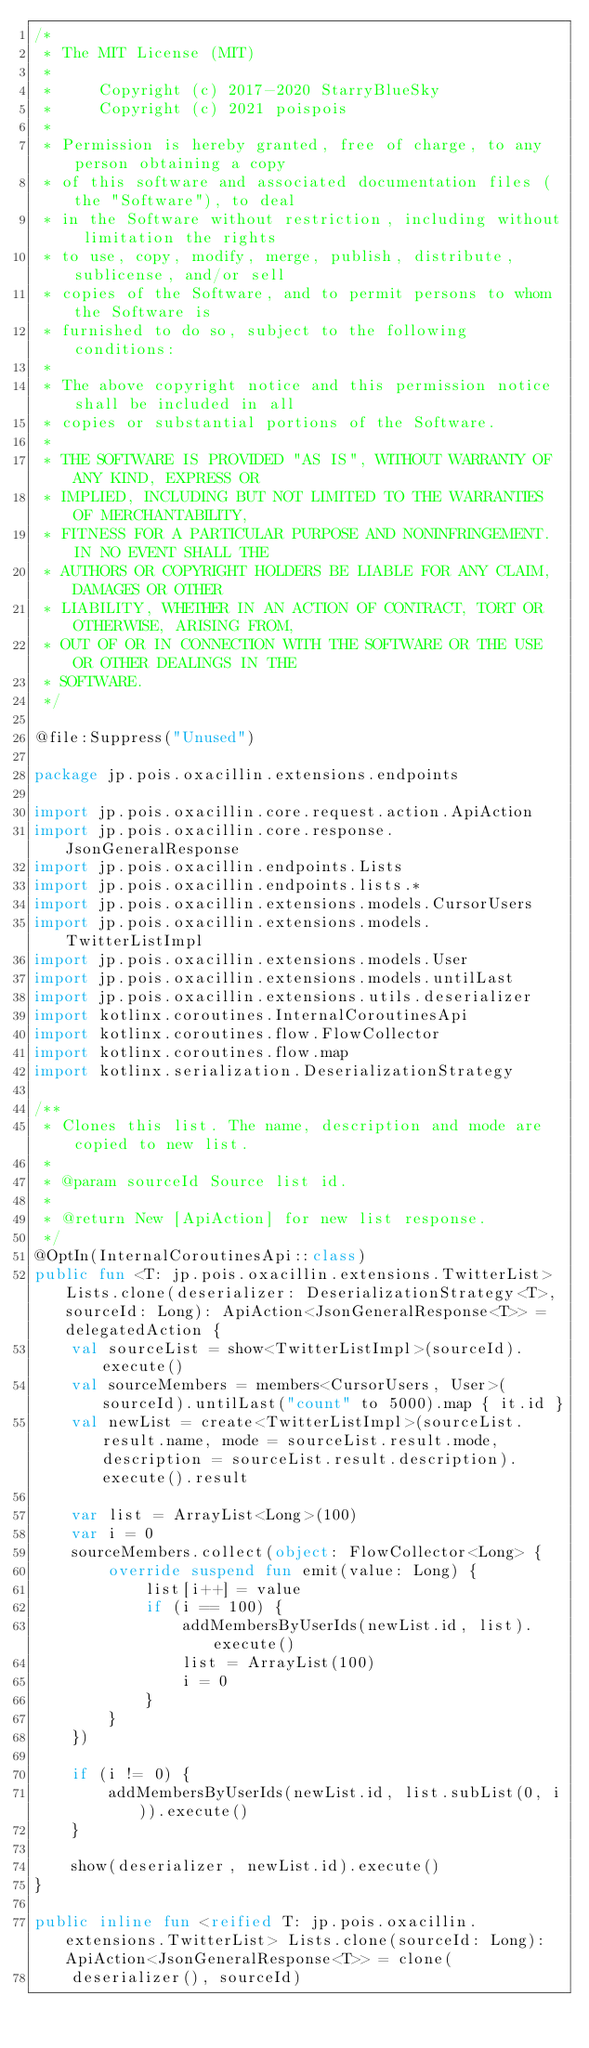Convert code to text. <code><loc_0><loc_0><loc_500><loc_500><_Kotlin_>/*
 * The MIT License (MIT)
 *
 *     Copyright (c) 2017-2020 StarryBlueSky
 *     Copyright (c) 2021 poispois
 *
 * Permission is hereby granted, free of charge, to any person obtaining a copy
 * of this software and associated documentation files (the "Software"), to deal
 * in the Software without restriction, including without limitation the rights
 * to use, copy, modify, merge, publish, distribute, sublicense, and/or sell
 * copies of the Software, and to permit persons to whom the Software is
 * furnished to do so, subject to the following conditions:
 *
 * The above copyright notice and this permission notice shall be included in all
 * copies or substantial portions of the Software.
 *
 * THE SOFTWARE IS PROVIDED "AS IS", WITHOUT WARRANTY OF ANY KIND, EXPRESS OR
 * IMPLIED, INCLUDING BUT NOT LIMITED TO THE WARRANTIES OF MERCHANTABILITY,
 * FITNESS FOR A PARTICULAR PURPOSE AND NONINFRINGEMENT. IN NO EVENT SHALL THE
 * AUTHORS OR COPYRIGHT HOLDERS BE LIABLE FOR ANY CLAIM, DAMAGES OR OTHER
 * LIABILITY, WHETHER IN AN ACTION OF CONTRACT, TORT OR OTHERWISE, ARISING FROM,
 * OUT OF OR IN CONNECTION WITH THE SOFTWARE OR THE USE OR OTHER DEALINGS IN THE
 * SOFTWARE.
 */

@file:Suppress("Unused")

package jp.pois.oxacillin.extensions.endpoints

import jp.pois.oxacillin.core.request.action.ApiAction
import jp.pois.oxacillin.core.response.JsonGeneralResponse
import jp.pois.oxacillin.endpoints.Lists
import jp.pois.oxacillin.endpoints.lists.*
import jp.pois.oxacillin.extensions.models.CursorUsers
import jp.pois.oxacillin.extensions.models.TwitterListImpl
import jp.pois.oxacillin.extensions.models.User
import jp.pois.oxacillin.extensions.models.untilLast
import jp.pois.oxacillin.extensions.utils.deserializer
import kotlinx.coroutines.InternalCoroutinesApi
import kotlinx.coroutines.flow.FlowCollector
import kotlinx.coroutines.flow.map
import kotlinx.serialization.DeserializationStrategy

/**
 * Clones this list. The name, description and mode are copied to new list.
 *
 * @param sourceId Source list id.
 *
 * @return New [ApiAction] for new list response.
 */
@OptIn(InternalCoroutinesApi::class)
public fun <T: jp.pois.oxacillin.extensions.TwitterList> Lists.clone(deserializer: DeserializationStrategy<T>, sourceId: Long): ApiAction<JsonGeneralResponse<T>> = delegatedAction {
    val sourceList = show<TwitterListImpl>(sourceId).execute()
    val sourceMembers = members<CursorUsers, User>(sourceId).untilLast("count" to 5000).map { it.id }
    val newList = create<TwitterListImpl>(sourceList.result.name, mode = sourceList.result.mode, description = sourceList.result.description).execute().result

    var list = ArrayList<Long>(100)
    var i = 0
    sourceMembers.collect(object: FlowCollector<Long> {
        override suspend fun emit(value: Long) {
            list[i++] = value
            if (i == 100) {
                addMembersByUserIds(newList.id, list).execute()
                list = ArrayList(100)
                i = 0
            }
        }
    })

    if (i != 0) {
        addMembersByUserIds(newList.id, list.subList(0, i)).execute()
    }

    show(deserializer, newList.id).execute()
}

public inline fun <reified T: jp.pois.oxacillin.extensions.TwitterList> Lists.clone(sourceId: Long): ApiAction<JsonGeneralResponse<T>> = clone(
    deserializer(), sourceId)
</code> 